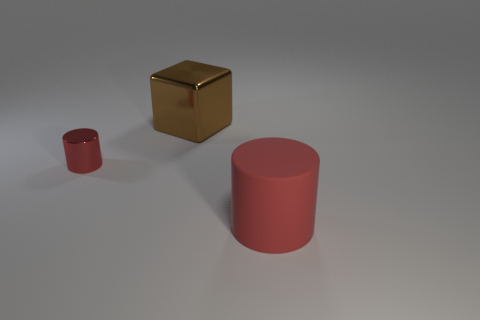Is there any other thing that is the same color as the big cylinder?
Ensure brevity in your answer.  Yes. What is the shape of the red thing that is right of the large metal thing?
Provide a succinct answer. Cylinder. The object that is right of the tiny red shiny thing and in front of the large shiny object has what shape?
Your response must be concise. Cylinder. What number of blue objects are small shiny cylinders or rubber cylinders?
Provide a succinct answer. 0. Do the large metallic cube behind the red matte object and the large cylinder have the same color?
Offer a terse response. No. What is the size of the red object behind the thing that is right of the brown block?
Your answer should be very brief. Small. What material is the red object that is the same size as the block?
Your answer should be compact. Rubber. How many other objects are the same size as the brown metallic block?
Your response must be concise. 1. How many cylinders are either big shiny objects or big matte things?
Your answer should be compact. 1. Is there anything else that has the same material as the large cylinder?
Your response must be concise. No. 